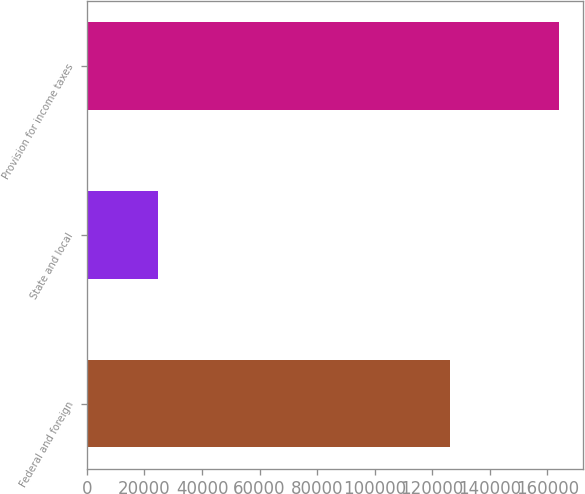<chart> <loc_0><loc_0><loc_500><loc_500><bar_chart><fcel>Federal and foreign<fcel>State and local<fcel>Provision for income taxes<nl><fcel>126075<fcel>24651<fcel>164098<nl></chart> 